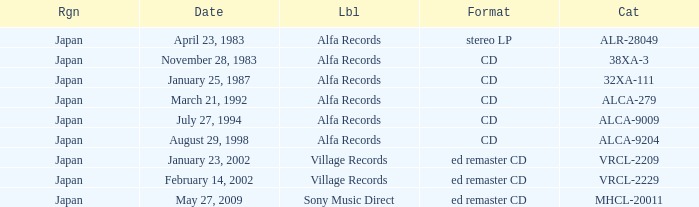Can you give me this table as a dict? {'header': ['Rgn', 'Date', 'Lbl', 'Format', 'Cat'], 'rows': [['Japan', 'April 23, 1983', 'Alfa Records', 'stereo LP', 'ALR-28049'], ['Japan', 'November 28, 1983', 'Alfa Records', 'CD', '38XA-3'], ['Japan', 'January 25, 1987', 'Alfa Records', 'CD', '32XA-111'], ['Japan', 'March 21, 1992', 'Alfa Records', 'CD', 'ALCA-279'], ['Japan', 'July 27, 1994', 'Alfa Records', 'CD', 'ALCA-9009'], ['Japan', 'August 29, 1998', 'Alfa Records', 'CD', 'ALCA-9204'], ['Japan', 'January 23, 2002', 'Village Records', 'ed remaster CD', 'VRCL-2209'], ['Japan', 'February 14, 2002', 'Village Records', 'ed remaster CD', 'VRCL-2229'], ['Japan', 'May 27, 2009', 'Sony Music Direct', 'ed remaster CD', 'MHCL-20011']]} Which region is identified as 38xa-3 in the catalog? Japan. 